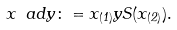Convert formula to latex. <formula><loc_0><loc_0><loc_500><loc_500>x \ a d y \colon = x _ { ( 1 ) } y S ( x _ { ( 2 ) } ) .</formula> 